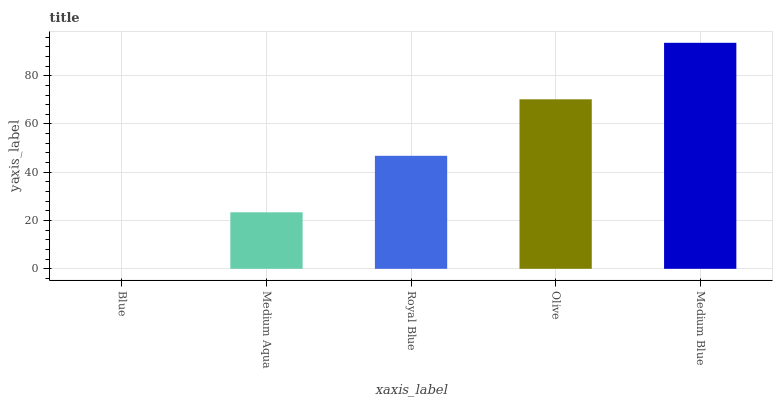Is Blue the minimum?
Answer yes or no. Yes. Is Medium Blue the maximum?
Answer yes or no. Yes. Is Medium Aqua the minimum?
Answer yes or no. No. Is Medium Aqua the maximum?
Answer yes or no. No. Is Medium Aqua greater than Blue?
Answer yes or no. Yes. Is Blue less than Medium Aqua?
Answer yes or no. Yes. Is Blue greater than Medium Aqua?
Answer yes or no. No. Is Medium Aqua less than Blue?
Answer yes or no. No. Is Royal Blue the high median?
Answer yes or no. Yes. Is Royal Blue the low median?
Answer yes or no. Yes. Is Medium Blue the high median?
Answer yes or no. No. Is Medium Blue the low median?
Answer yes or no. No. 